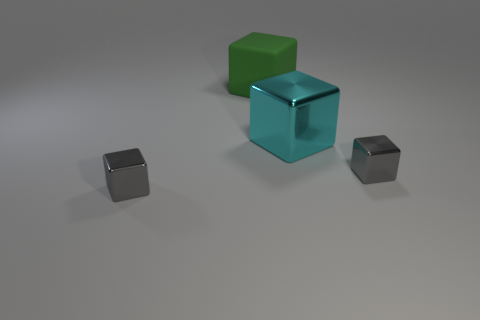Is there any other thing that is the same material as the green cube?
Keep it short and to the point. No. Are there fewer big rubber things to the right of the big cyan cube than cyan blocks?
Keep it short and to the point. Yes. Is the shape of the big green thing behind the large cyan metallic block the same as the gray metallic thing right of the rubber block?
Your answer should be very brief. Yes. Is the number of green rubber cubes that are behind the big cyan metallic cube less than the number of objects on the right side of the green block?
Provide a short and direct response. Yes. What number of cyan cylinders have the same size as the rubber thing?
Offer a terse response. 0. Is the material of the tiny thing on the left side of the big matte object the same as the green thing?
Your answer should be very brief. No. Are there any tiny gray metal things?
Offer a terse response. Yes. Are there any large metallic blocks that have the same color as the matte cube?
Provide a short and direct response. No. There is a small metal block that is on the left side of the large green matte block; does it have the same color as the small shiny block right of the large green matte cube?
Keep it short and to the point. Yes. Are there any small gray blocks that have the same material as the cyan object?
Keep it short and to the point. Yes. 